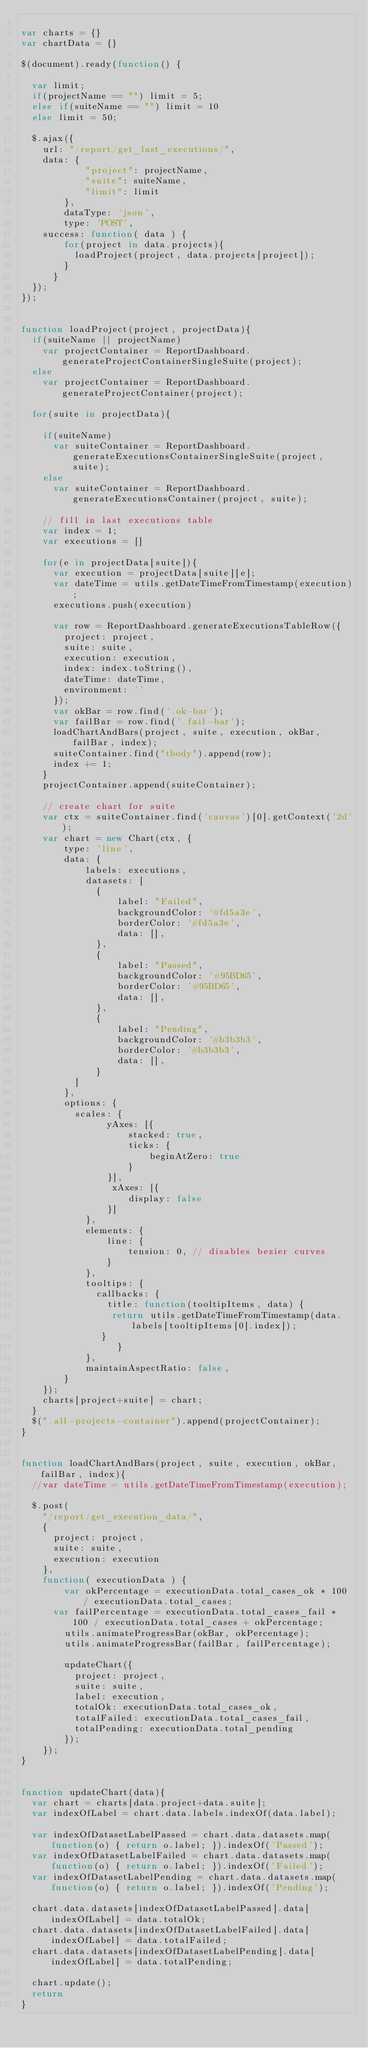<code> <loc_0><loc_0><loc_500><loc_500><_JavaScript_>
var charts = {}
var chartData = {}

$(document).ready(function() {

	var limit;
	if(projectName == "") limit = 5;
	else if(suiteName == "") limit = 10
	else limit = 50;

	$.ajax({
		url: "/report/get_last_executions/",
		data: {
            "project": projectName,
            "suite": suiteName,
            "limit": limit
        },
        dataType: 'json',
        type: 'POST',
		success: function( data ) {	
	  		for(project in data.projects){
	  			loadProject(project, data.projects[project]);
	  		}
	  	}
	});
});


function loadProject(project, projectData){
	if(suiteName || projectName)
		var projectContainer = ReportDashboard.generateProjectContainerSingleSuite(project);
	else
		var projectContainer = ReportDashboard.generateProjectContainer(project);

	for(suite in projectData){

		if(suiteName)
			var suiteContainer = ReportDashboard.generateExecutionsContainerSingleSuite(project, suite);
		else
			var suiteContainer = ReportDashboard.generateExecutionsContainer(project, suite);
		
		// fill in last executions table
		var index = 1;
		var executions = []

		for(e in projectData[suite]){
			var execution = projectData[suite][e];
			var dateTime = utils.getDateTimeFromTimestamp(execution);
			executions.push(execution)

			var row = ReportDashboard.generateExecutionsTableRow({
				project: project,
				suite: suite,
				execution: execution,
				index: index.toString(),
				dateTime: dateTime,
				environment: ''
			});
			var okBar = row.find('.ok-bar');
			var failBar = row.find('.fail-bar');
			loadChartAndBars(project, suite, execution, okBar, failBar, index);
			suiteContainer.find("tbody").append(row);
			index += 1;
		}
		projectContainer.append(suiteContainer);

		// create chart for suite
		var ctx = suiteContainer.find('canvas')[0].getContext('2d');
		var chart = new Chart(ctx, {
		    type: 'line',
		    data: {
		        labels: executions,
		        datasets: [
			        {
			            label: "Failed",
			            backgroundColor: '#fd5a3e',
			            borderColor: '#fd5a3e',
			            data: [],
			        },
			        {
			            label: "Passed",
			            backgroundColor: '#95BD65',
			            borderColor: '#95BD65',
			            data: [],
			        },
			        {
			            label: "Pending",
			            backgroundColor: '#b3b3b3',
			            borderColor: '#b3b3b3',
			            data: [],
			        }
		    	]
	    	},
	    	options: {
	    		scales: {
		            yAxes: [{
		                stacked: true,
		                ticks: {
		                    beginAtZero: true
		                }
		            }],
		             xAxes: [{
		                display: false
		            }]
		        },
		        elements: {
		            line: {
		                tension: 0, // disables bezier curves
		            }
		        },
		        tooltips: {
		        	callbacks: {
		        		title: function(tooltipItems, data) {
					       return utils.getDateTimeFromTimestamp(data.labels[tooltipItems[0].index]);
					     }
                	}
		        },
		        maintainAspectRatio: false,
	    	}
		});
		charts[project+suite] = chart;
	}
	$(".all-projects-container").append(projectContainer);
}


function loadChartAndBars(project, suite, execution, okBar, failBar, index){
	//var dateTime = utils.getDateTimeFromTimestamp(execution);

	$.post( 
		"/report/get_execution_data/",
		{
			project: project,
			suite: suite,
			execution: execution
		},
		function( executionData ) {
  			var okPercentage = executionData.total_cases_ok * 100 / executionData.total_cases;
			var failPercentage = executionData.total_cases_fail * 100 / executionData.total_cases + okPercentage;
  			utils.animateProgressBar(okBar, okPercentage);
  			utils.animateProgressBar(failBar, failPercentage);

  			updateChart({
  				project: project,
  				suite: suite,
  				label: execution,
  				totalOk: executionData.total_cases_ok,
  				totalFailed: executionData.total_cases_fail,
  				totalPending: executionData.total_pending
  			});
		});
}


function updateChart(data){
	var chart = charts[data.project+data.suite];
	var indexOfLabel = chart.data.labels.indexOf(data.label);

	var indexOfDatasetLabelPassed = chart.data.datasets.map(function(o) { return o.label; }).indexOf('Passed');
	var indexOfDatasetLabelFailed = chart.data.datasets.map(function(o) { return o.label; }).indexOf('Failed');
	var indexOfDatasetLabelPending = chart.data.datasets.map(function(o) { return o.label; }).indexOf('Pending');

	chart.data.datasets[indexOfDatasetLabelPassed].data[indexOfLabel] = data.totalOk;
	chart.data.datasets[indexOfDatasetLabelFailed].data[indexOfLabel] = data.totalFailed;
	chart.data.datasets[indexOfDatasetLabelPending].data[indexOfLabel] = data.totalPending;

	chart.update();
	return
}</code> 